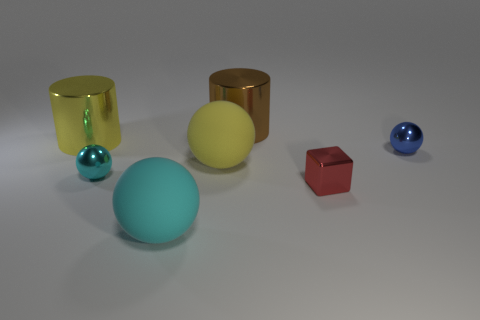What color is the cube that is made of the same material as the small blue object?
Provide a short and direct response. Red. There is a small blue thing; is it the same shape as the tiny thing to the left of the red shiny thing?
Your answer should be very brief. Yes. There is a blue object that is the same size as the red cube; what is it made of?
Offer a terse response. Metal. Is there a metal sphere that has the same color as the small metal block?
Offer a very short reply. No. There is a object that is in front of the yellow rubber object and left of the big cyan matte ball; what shape is it?
Give a very brief answer. Sphere. What number of yellow cylinders have the same material as the small red thing?
Provide a short and direct response. 1. Is the number of brown cylinders to the left of the cyan rubber object less than the number of tiny shiny objects behind the yellow matte thing?
Your answer should be very brief. Yes. What is the material of the cylinder that is in front of the big shiny cylinder that is on the right side of the cyan thing in front of the cyan shiny ball?
Your answer should be very brief. Metal. There is a sphere that is both behind the small red object and on the left side of the yellow matte thing; how big is it?
Make the answer very short. Small. What number of cubes are either metallic objects or matte objects?
Ensure brevity in your answer.  1. 